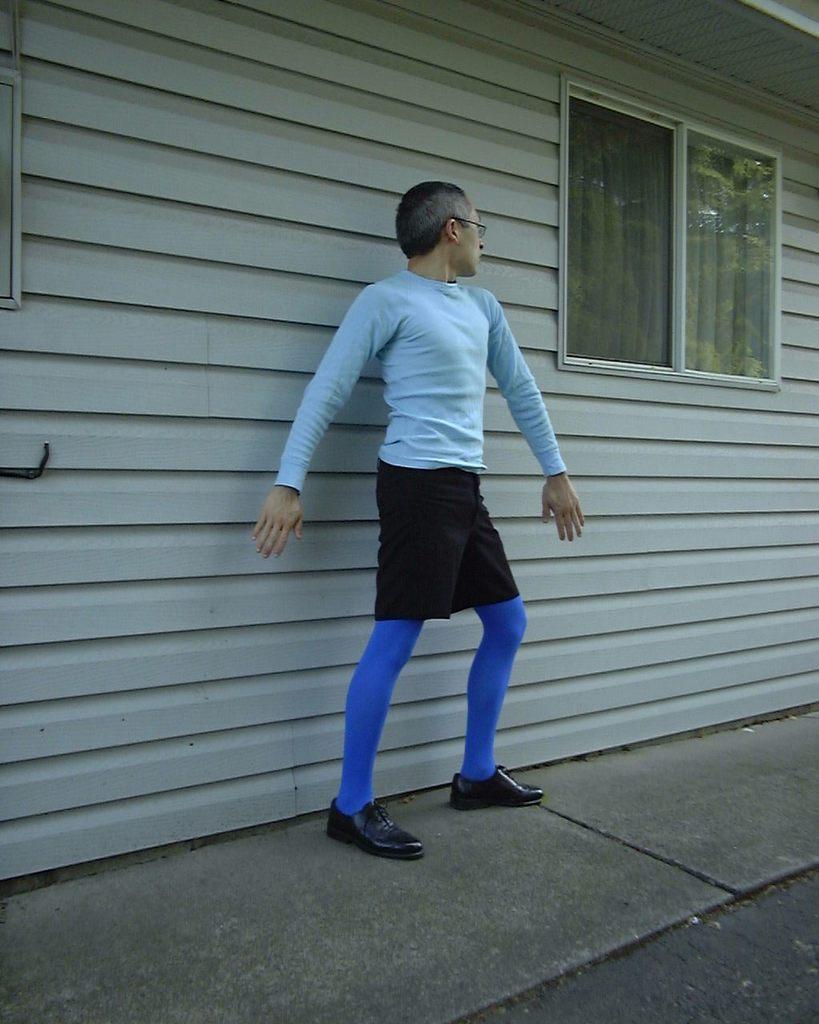Please provide a concise description of this image. In this image in the middle, there is a man, he wears a t shirt, trouser, shoes. At the bottom there is floor. In the background there is house, window, glass, curtain and wall. 